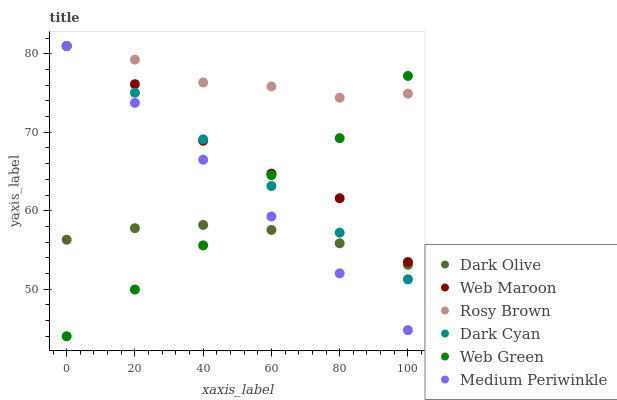Does Dark Olive have the minimum area under the curve?
Answer yes or no. Yes. Does Rosy Brown have the maximum area under the curve?
Answer yes or no. Yes. Does Web Maroon have the minimum area under the curve?
Answer yes or no. No. Does Web Maroon have the maximum area under the curve?
Answer yes or no. No. Is Medium Periwinkle the smoothest?
Answer yes or no. Yes. Is Web Maroon the roughest?
Answer yes or no. Yes. Is Rosy Brown the smoothest?
Answer yes or no. No. Is Rosy Brown the roughest?
Answer yes or no. No. Does Web Green have the lowest value?
Answer yes or no. Yes. Does Web Maroon have the lowest value?
Answer yes or no. No. Does Dark Cyan have the highest value?
Answer yes or no. Yes. Does Web Green have the highest value?
Answer yes or no. No. Is Dark Olive less than Web Maroon?
Answer yes or no. Yes. Is Rosy Brown greater than Dark Olive?
Answer yes or no. Yes. Does Web Green intersect Web Maroon?
Answer yes or no. Yes. Is Web Green less than Web Maroon?
Answer yes or no. No. Is Web Green greater than Web Maroon?
Answer yes or no. No. Does Dark Olive intersect Web Maroon?
Answer yes or no. No. 